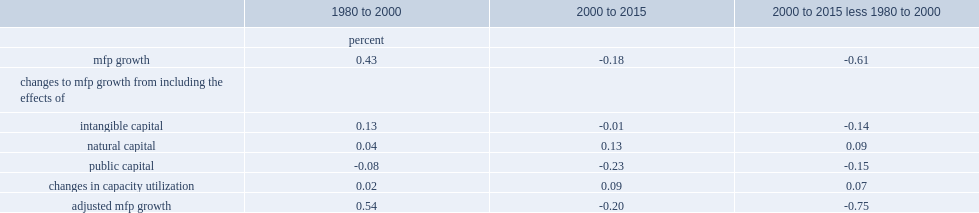Parse the full table. {'header': ['', '1980 to 2000', '2000 to 2015', '2000 to 2015 less 1980 to 2000'], 'rows': [['', 'percent', '', ''], ['mfp growth', '0.43', '-0.18', '-0.61'], ['changes to mfp growth from including the effects of', '', '', ''], ['intangible capital', '0.13', '-0.01', '-0.14'], ['natural capital', '0.04', '0.13', '0.09'], ['public capital', '-0.08', '-0.23', '-0.15'], ['changes in capacity utilization', '0.02', '0.09', '0.07'], ['adjusted mfp growth', '0.54', '-0.20', '-0.75']]} What's the percent that mfp growth declined in the two periods? 0.61. What's the percent that mfp growth increased from 1980 to 2000? 0.43. What's the percent that mfp growth decreased from 2000 to 2015? 0.18. What's the percent that mfp growth slowed in the two periods, when natural capital and changes in capital utilization are taken into account? 0.45. What's the percent that mfp growth was from 1980 to 2000, when natural capital and changes in capital utilization are taken into account? 0.49. What's the percent that mfp growth was from 2000 to 2015, when natural capital and changes in capital utilization are taken into account? 0.04. 